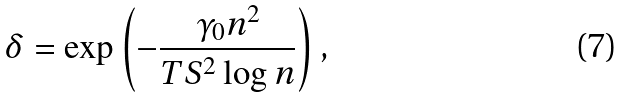Convert formula to latex. <formula><loc_0><loc_0><loc_500><loc_500>\delta = \exp \left ( - \frac { \gamma _ { 0 } n ^ { 2 } } { T S ^ { 2 } \log n } \right ) ,</formula> 